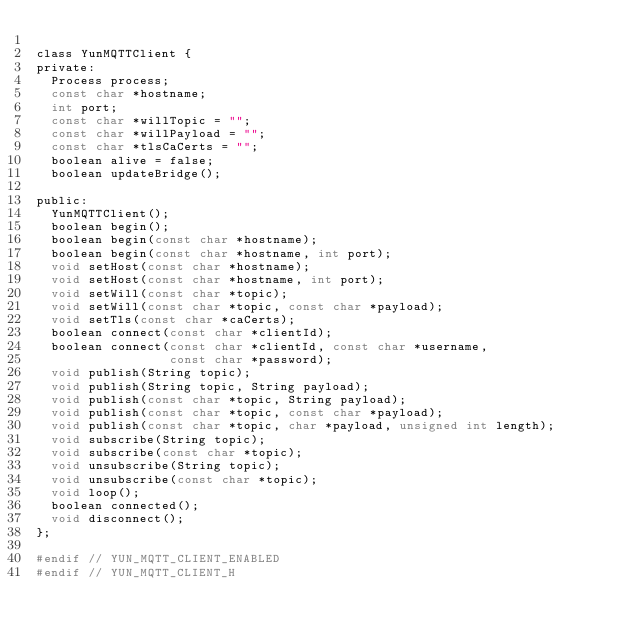<code> <loc_0><loc_0><loc_500><loc_500><_C_>
class YunMQTTClient {
private:
  Process process;
  const char *hostname;
  int port;
  const char *willTopic = "";
  const char *willPayload = "";
  const char *tlsCaCerts = "";
  boolean alive = false;
  boolean updateBridge();

public:
  YunMQTTClient();
  boolean begin();
  boolean begin(const char *hostname);
  boolean begin(const char *hostname, int port);
  void setHost(const char *hostname);
  void setHost(const char *hostname, int port);
  void setWill(const char *topic);
  void setWill(const char *topic, const char *payload);
  void setTls(const char *caCerts);
  boolean connect(const char *clientId);
  boolean connect(const char *clientId, const char *username,
                  const char *password);
  void publish(String topic);
  void publish(String topic, String payload);
  void publish(const char *topic, String payload);
  void publish(const char *topic, const char *payload);
  void publish(const char *topic, char *payload, unsigned int length);
  void subscribe(String topic);
  void subscribe(const char *topic);
  void unsubscribe(String topic);
  void unsubscribe(const char *topic);
  void loop();
  boolean connected();
  void disconnect();
};

#endif // YUN_MQTT_CLIENT_ENABLED
#endif // YUN_MQTT_CLIENT_H
</code> 